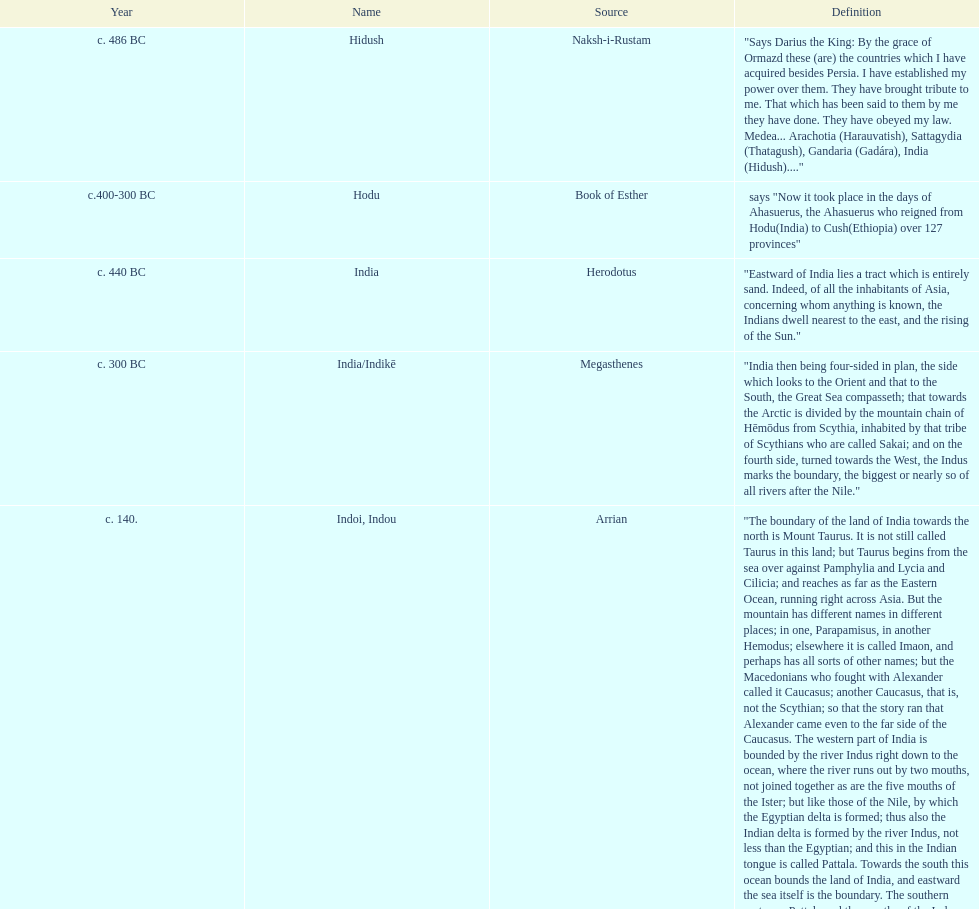What was the nation called before the book of esther called it hodu? Hidush. 